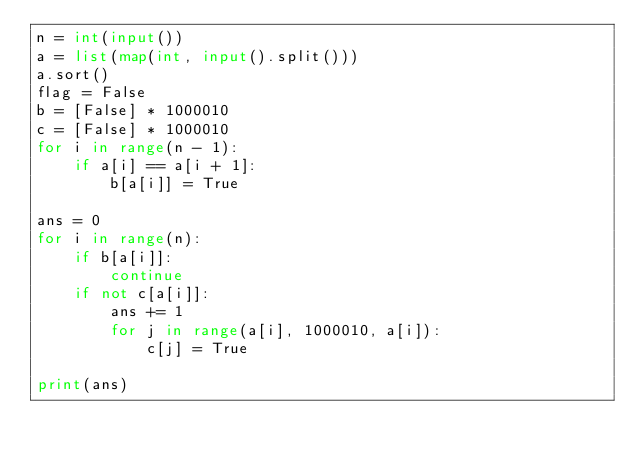<code> <loc_0><loc_0><loc_500><loc_500><_Python_>n = int(input())
a = list(map(int, input().split()))
a.sort()
flag = False
b = [False] * 1000010
c = [False] * 1000010
for i in range(n - 1):
    if a[i] == a[i + 1]:
        b[a[i]] = True

ans = 0
for i in range(n):
    if b[a[i]]:
        continue
    if not c[a[i]]:
        ans += 1
        for j in range(a[i], 1000010, a[i]):
            c[j] = True

print(ans)
</code> 